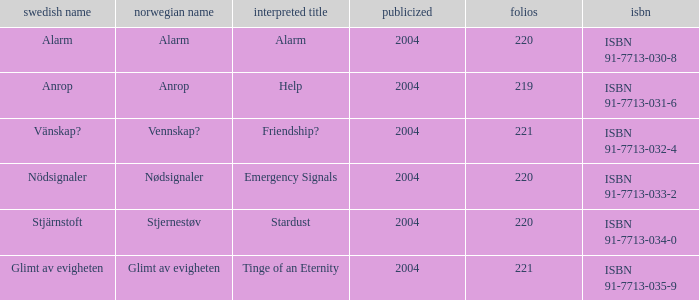How many pages associated with isbn 91-7713-035-9? 221.0. 